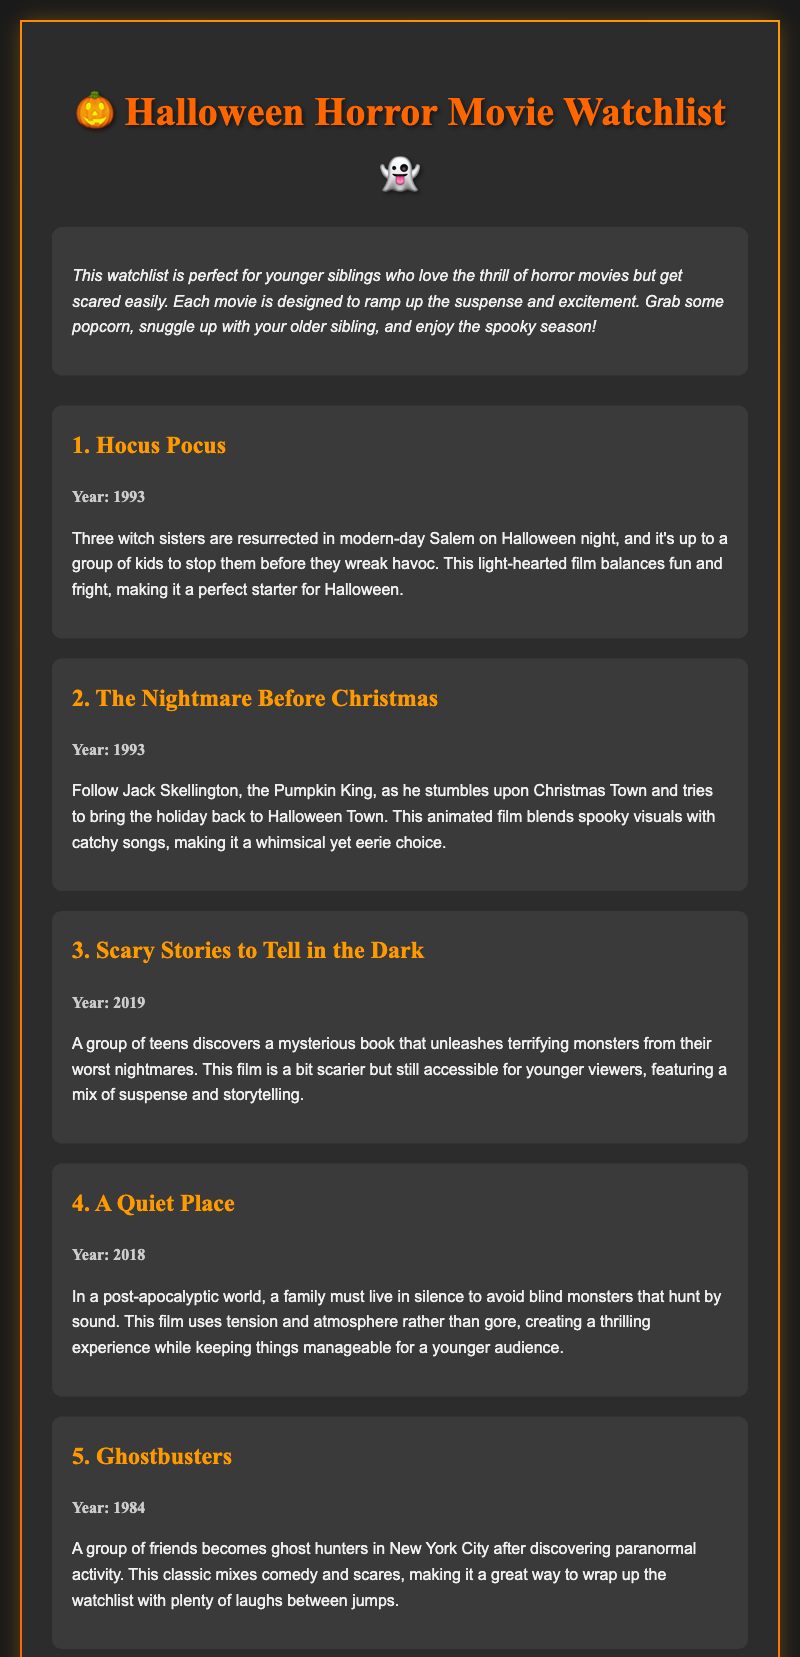What is the title of the document? The title of the document is presented in the heading, which is "Halloween Horror Movie Watchlist."
Answer: Halloween Horror Movie Watchlist How many movies are listed in the watchlist? The document lists a total of five movies in the watchlist.
Answer: 5 What year was "Hocus Pocus" released? The movie "Hocus Pocus" is noted to have been released in 1993.
Answer: 1993 Which movie features Jack Skellington? The movie featuring Jack Skellington is "The Nightmare Before Christmas."
Answer: The Nightmare Before Christmas What is the primary theme of "A Quiet Place"? The primary theme of "A Quiet Place" involves a family living in silence to avoid monsters that hunt by sound.
Answer: Silence to avoid monsters Which movie is described as a blend of comedy and scares? The movie described as a blend of comedy and scares is "Ghostbusters."
Answer: Ghostbusters What genre does "Scary Stories to Tell in the Dark" belong to? "Scary Stories to Tell in the Dark" is categorized as a horror movie.
Answer: Horror What is the overall targeted audience for this watchlist? The watchlist is specifically targeted towards younger siblings who enjoy horror movies but may get scared easily.
Answer: Younger siblings In what year was "A Quiet Place" released? "A Quiet Place" was released in the year 2018 according to the document.
Answer: 2018 